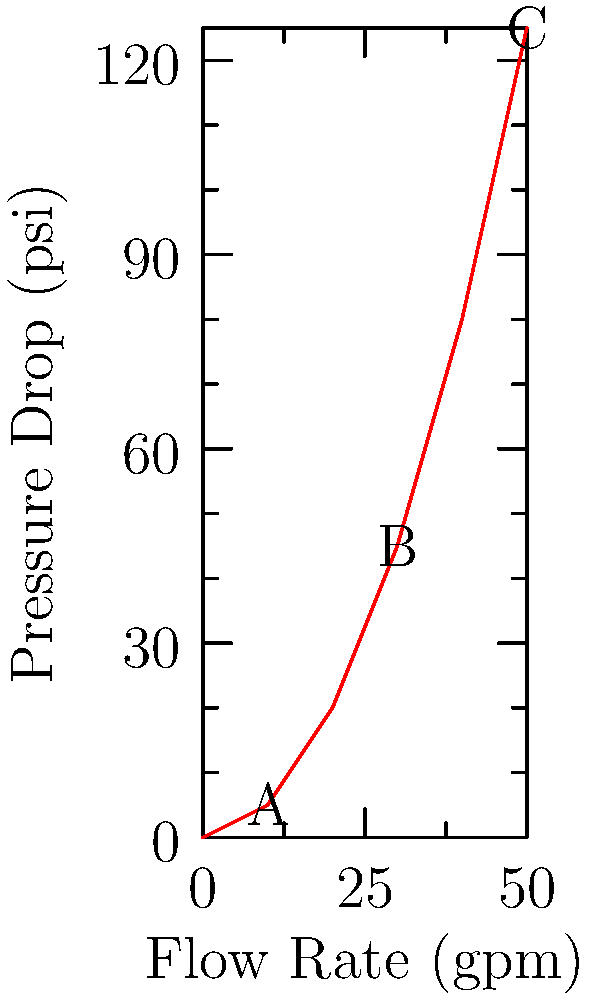As a manufacturing plant manager overseeing fluid transport systems, you're analyzing a new piping configuration. The graph shows the relationship between flow rate and pressure drop for the system. If the pump can provide a maximum pressure of 100 psi, what is the highest flow rate (in gpm) that can be achieved without exceeding this pressure limit? To solve this problem, we need to follow these steps:

1. Understand the graph: The x-axis represents flow rate in gpm (gallons per minute), and the y-axis represents pressure drop in psi (pounds per square inch).

2. Identify the constraint: The pump can provide a maximum pressure of 100 psi.

3. Analyze the pressure drop curve: As the flow rate increases, the pressure drop increases non-linearly.

4. Find the point where pressure drop equals 100 psi: This is the maximum flow rate we can achieve without exceeding the pump's capability.

5. Estimate the flow rate: By visually interpolating between points B (30 gpm, 45 psi) and C (50 gpm, 125 psi), we can estimate that 100 psi corresponds to approximately 45 gpm.

6. Verify: At 40 gpm, the pressure drop is 80 psi (below our limit), and at 50 gpm, it's 125 psi (above our limit). This confirms our estimate is reasonable.

Therefore, the highest flow rate that can be achieved without exceeding the 100 psi pressure limit is approximately 45 gpm.
Answer: 45 gpm 